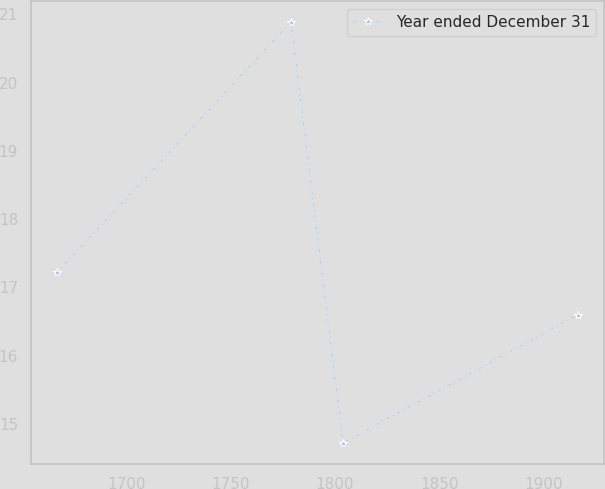Convert chart to OTSL. <chart><loc_0><loc_0><loc_500><loc_500><line_chart><ecel><fcel>Year ended December 31<nl><fcel>1667.07<fcel>17.22<nl><fcel>1779.01<fcel>20.89<nl><fcel>1803.96<fcel>14.72<nl><fcel>1916.56<fcel>16.6<nl></chart> 